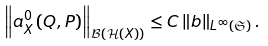<formula> <loc_0><loc_0><loc_500><loc_500>\left \| a _ { X } ^ { 0 } \left ( Q , P \right ) \right \| _ { \mathcal { B } \left ( \mathcal { H } \left ( X \right ) \right ) } \leq C \left \| b \right \| _ { L ^ { \infty } \left ( \mathfrak { S } \right ) } .</formula> 